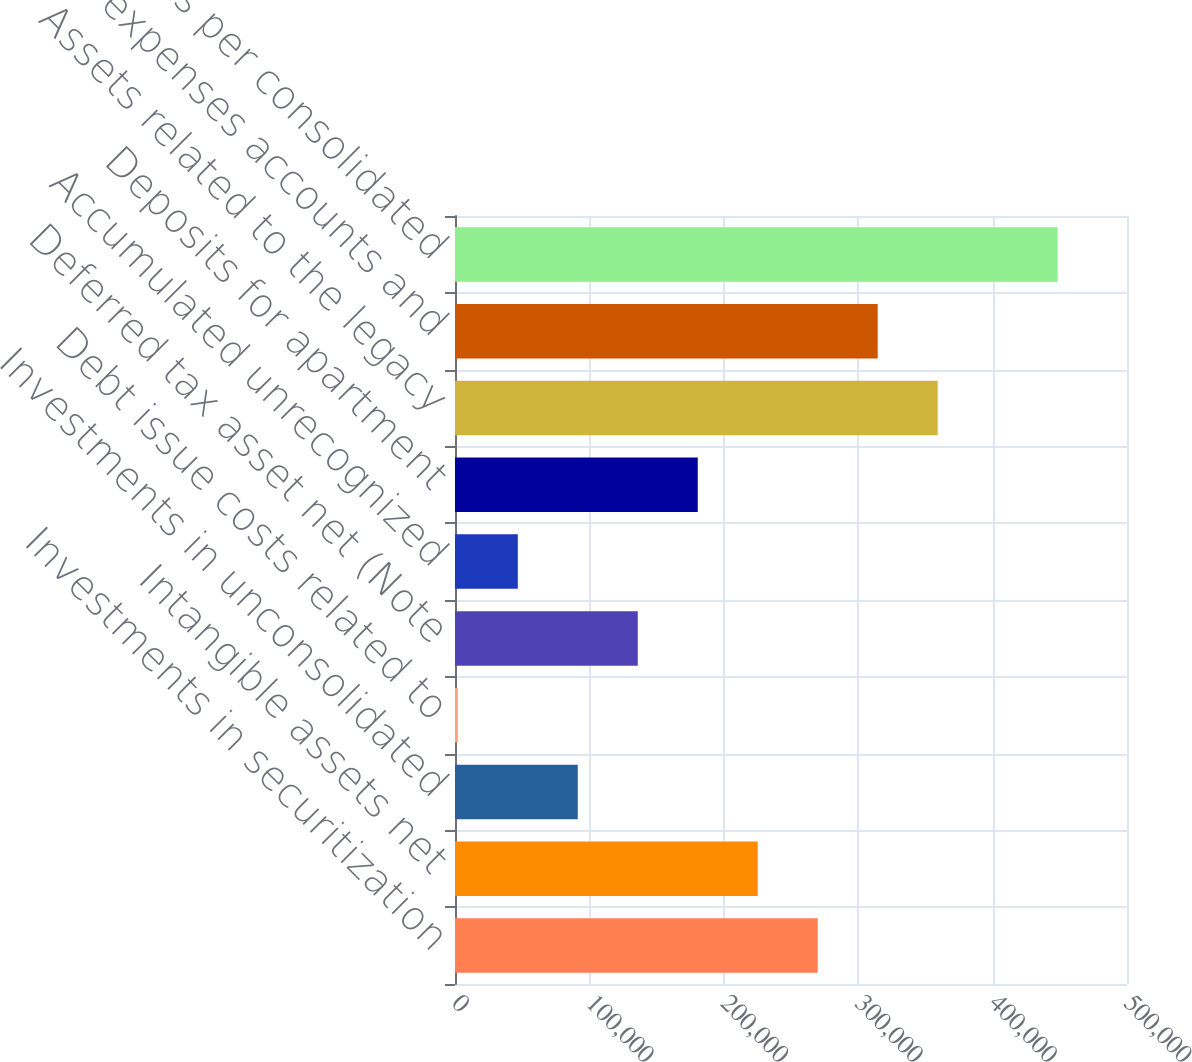Convert chart to OTSL. <chart><loc_0><loc_0><loc_500><loc_500><bar_chart><fcel>Investments in securitization<fcel>Intangible assets net<fcel>Investments in unconsolidated<fcel>Debt issue costs related to<fcel>Deferred tax asset net (Note<fcel>Accumulated unrecognized<fcel>Deposits for apartment<fcel>Assets related to the legacy<fcel>Prepaid expenses accounts and<fcel>Other assets per consolidated<nl><fcel>269886<fcel>225256<fcel>91366.6<fcel>2107<fcel>135996<fcel>46736.8<fcel>180626<fcel>359145<fcel>314516<fcel>448405<nl></chart> 